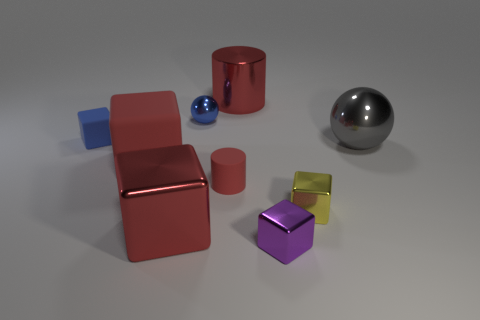Are there the same number of red rubber blocks that are to the right of the tiny red rubber cylinder and green rubber spheres?
Ensure brevity in your answer.  Yes. Does the gray shiny thing have the same shape as the tiny red thing?
Your answer should be very brief. No. Is there anything else that has the same color as the large metallic ball?
Keep it short and to the point. No. The thing that is both behind the small yellow block and to the right of the small purple object has what shape?
Make the answer very short. Sphere. Are there an equal number of big gray metal balls to the left of the large ball and purple metallic cubes behind the small metallic sphere?
Make the answer very short. Yes. What number of cylinders are purple things or large red things?
Offer a very short reply. 1. What number of big red cylinders are made of the same material as the large sphere?
Your answer should be compact. 1. There is a large matte object that is the same color as the large metallic cube; what shape is it?
Provide a short and direct response. Cube. The thing that is right of the blue metallic thing and behind the small blue block is made of what material?
Offer a terse response. Metal. The blue thing to the right of the blue rubber cube has what shape?
Offer a very short reply. Sphere. 